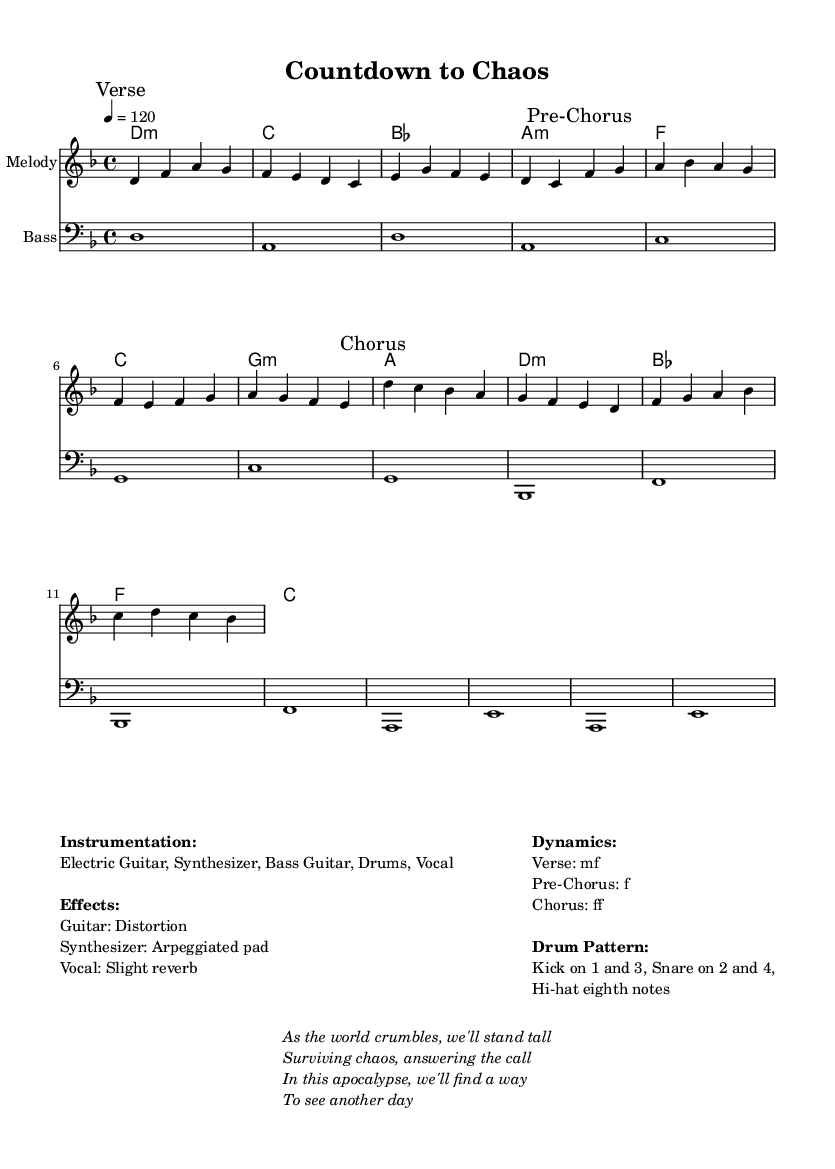What is the key signature of this music? The key signature is D minor, which has one flat (B♭). This can be determined by looking at the key mentioned in the global settings of the score.
Answer: D minor What is the time signature of the music? The time signature is 4/4, indicated in the global settings. This means there are four beats in each measure and the quarter note gets one beat.
Answer: 4/4 What is the tempo marking for this piece? The tempo marking is 120 beats per minute, as specified in the global settings. This means the piece should be played at a moderately fast pace.
Answer: 120 How many measures are in the Chorus section? The Chorus section consists of 8 measures. By counting the individual measures represented in the melody section marked "Chorus," we arrive at this total.
Answer: 8 What is the dynamics level for the Pre-Chorus? The dynamics level for the Pre-Chorus is marked as forte (f), indicating that this section should be played loudly. This information is directly provided under the Dynamics section in the markup.
Answer: f Which instruments are indicated in the instrumentation? The instrumentation includes Electric Guitar, Synthesizer, Bass Guitar, Drums, and Vocal. This information is listed under the Instrumentation section in the markup.
Answer: Electric Guitar, Synthesizer, Bass Guitar, Drums, Vocal What is the primary theme indicated in the lyrics? The primary theme in the lyrics is survival amidst chaos, as highlighted in the phrases provided in the markup, stressing resilience and hope in an apocalyptic scenario.
Answer: Survival amidst chaos 